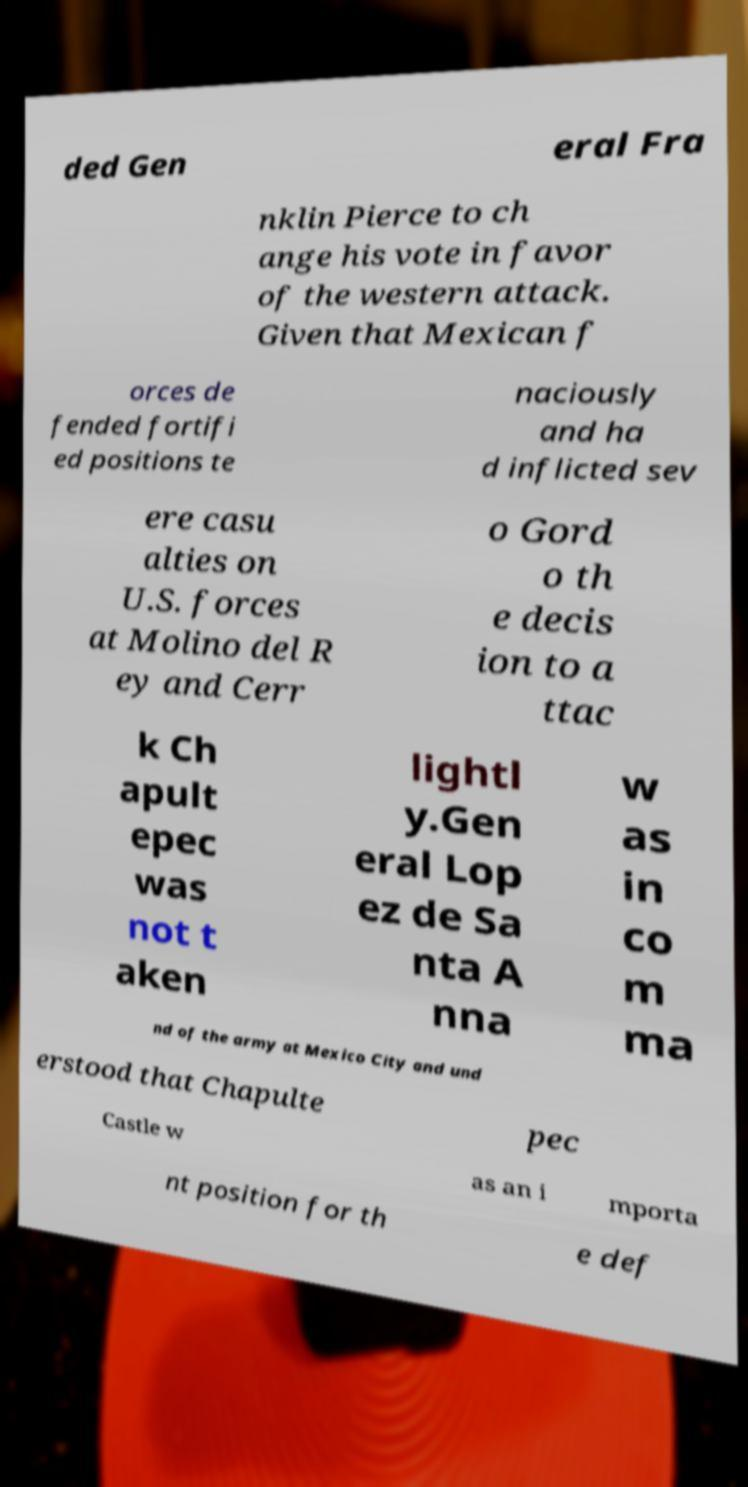Could you extract and type out the text from this image? ded Gen eral Fra nklin Pierce to ch ange his vote in favor of the western attack. Given that Mexican f orces de fended fortifi ed positions te naciously and ha d inflicted sev ere casu alties on U.S. forces at Molino del R ey and Cerr o Gord o th e decis ion to a ttac k Ch apult epec was not t aken lightl y.Gen eral Lop ez de Sa nta A nna w as in co m ma nd of the army at Mexico City and und erstood that Chapulte pec Castle w as an i mporta nt position for th e def 